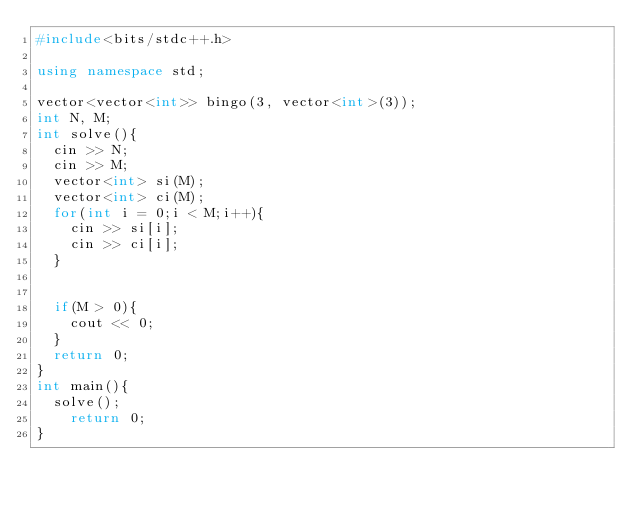<code> <loc_0><loc_0><loc_500><loc_500><_C++_>#include<bits/stdc++.h>
 
using namespace std;
 
vector<vector<int>> bingo(3, vector<int>(3));
int N, M;
int solve(){
  cin >> N;
  cin >> M;
  vector<int> si(M);
  vector<int> ci(M);
  for(int i = 0;i < M;i++){
  	cin >> si[i];
    cin >> ci[i];
  }
  
    
  if(M > 0){
    cout << 0;
  }
  return 0;
}
int main(){
	solve();
  	return 0;
}</code> 